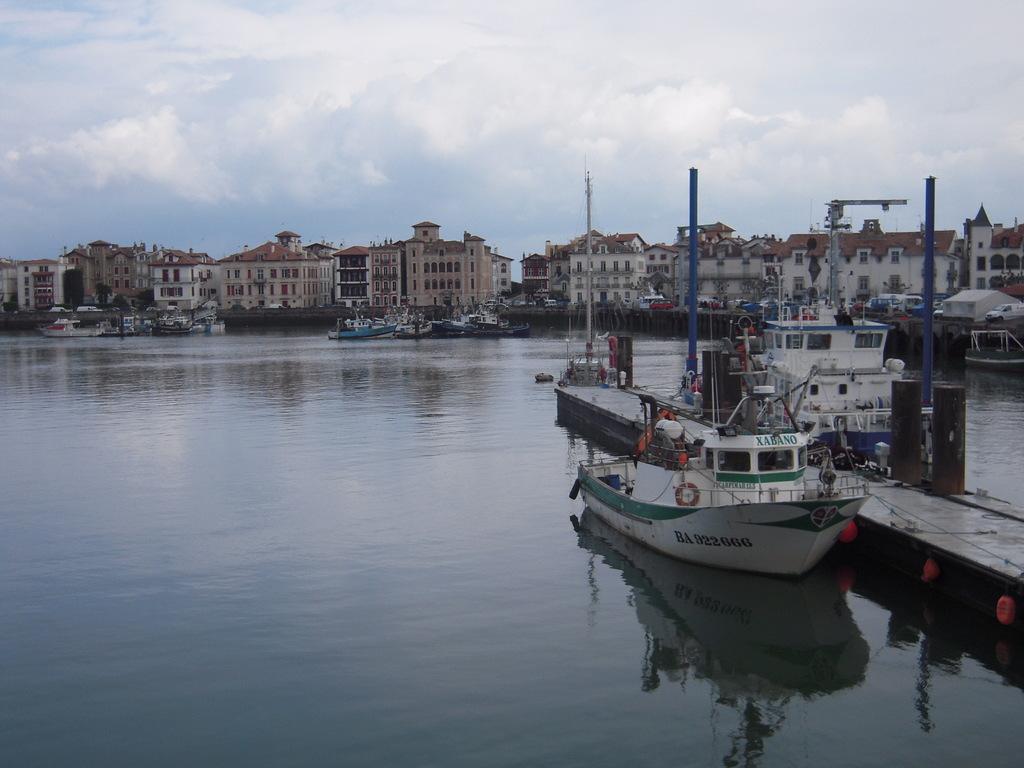What is on the boat?
Your answer should be very brief. Xabano. 